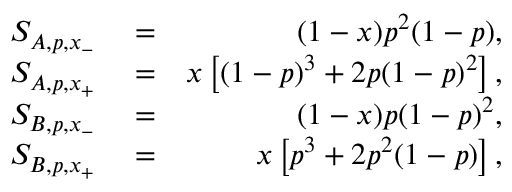<formula> <loc_0><loc_0><loc_500><loc_500>\begin{array} { r l r } { S _ { A , p , x _ { - } } } & = } & { ( 1 - x ) p ^ { 2 } ( 1 - p ) , } \\ { S _ { A , p , x _ { + } } } & = } & { x \left [ ( 1 - p ) ^ { 3 } + 2 p ( 1 - p ) ^ { 2 } \right ] , } \\ { S _ { B , p , x _ { - } } } & = } & { ( 1 - x ) p ( 1 - p ) ^ { 2 } , } \\ { S _ { B , p , x _ { + } } } & = } & { x \left [ p ^ { 3 } + 2 p ^ { 2 } ( 1 - p ) \right ] , } \end{array}</formula> 